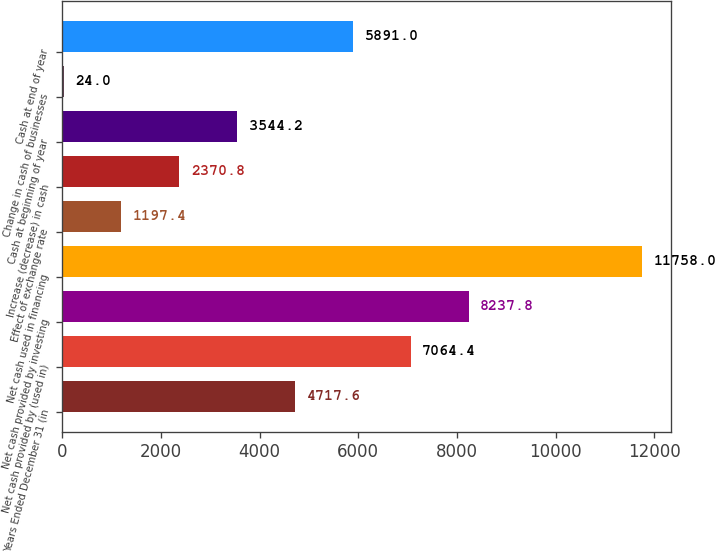Convert chart to OTSL. <chart><loc_0><loc_0><loc_500><loc_500><bar_chart><fcel>Years Ended December 31 (in<fcel>Net cash provided by (used in)<fcel>Net cash provided by investing<fcel>Net cash used in financing<fcel>Effect of exchange rate<fcel>Increase (decrease) in cash<fcel>Cash at beginning of year<fcel>Change in cash of businesses<fcel>Cash at end of year<nl><fcel>4717.6<fcel>7064.4<fcel>8237.8<fcel>11758<fcel>1197.4<fcel>2370.8<fcel>3544.2<fcel>24<fcel>5891<nl></chart> 